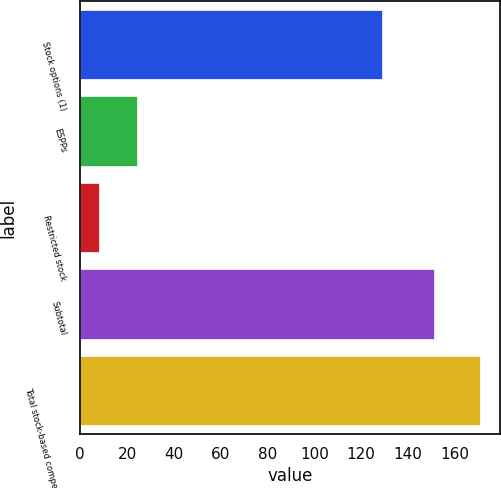Convert chart to OTSL. <chart><loc_0><loc_0><loc_500><loc_500><bar_chart><fcel>Stock options (1)<fcel>ESPPs<fcel>Restricted stock<fcel>Subtotal<fcel>Total stock-based compensation<nl><fcel>128.8<fcel>24.17<fcel>7.9<fcel>151.1<fcel>170.6<nl></chart> 